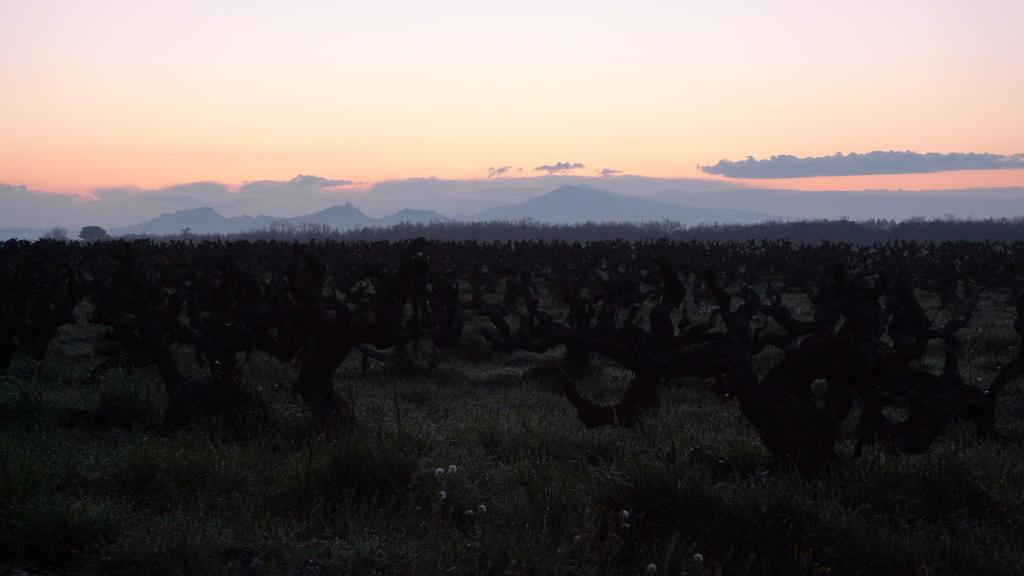What type of vegetation can be seen in the image? There is grass in the image. What other natural elements are present in the image? There are trees in the image. What can be seen in the distance in the image? There are mountains in the background of the image. What is visible in the sky in the image? There are clouds and the sky is visible in the background of the image. Can you hear the bell ringing in the image? There is no bell present in the image, so it cannot be heard. What type of pleasure can be seen in the image? There is no specific pleasure depicted in the image; it features natural elements such as grass, trees, mountains, clouds, and the sky. 